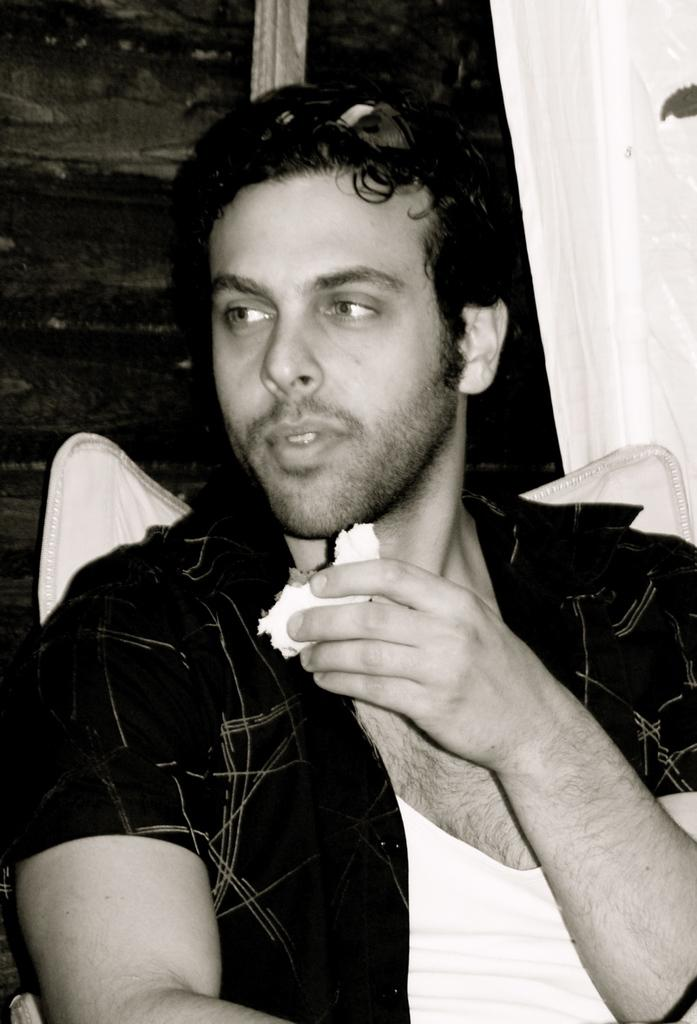Who is the main subject in the image? There is a man in the center of the image. What is the man holding in the image? The man is holding something. What can be seen in the background of the image? There is a wall in the background of the image. Is there any window treatment present in the image? Yes, there is a curtain associated with the wall in the background. What type of skin condition does the man have in the image? There is no indication of a skin condition in the image; the man's skin is not visible. 